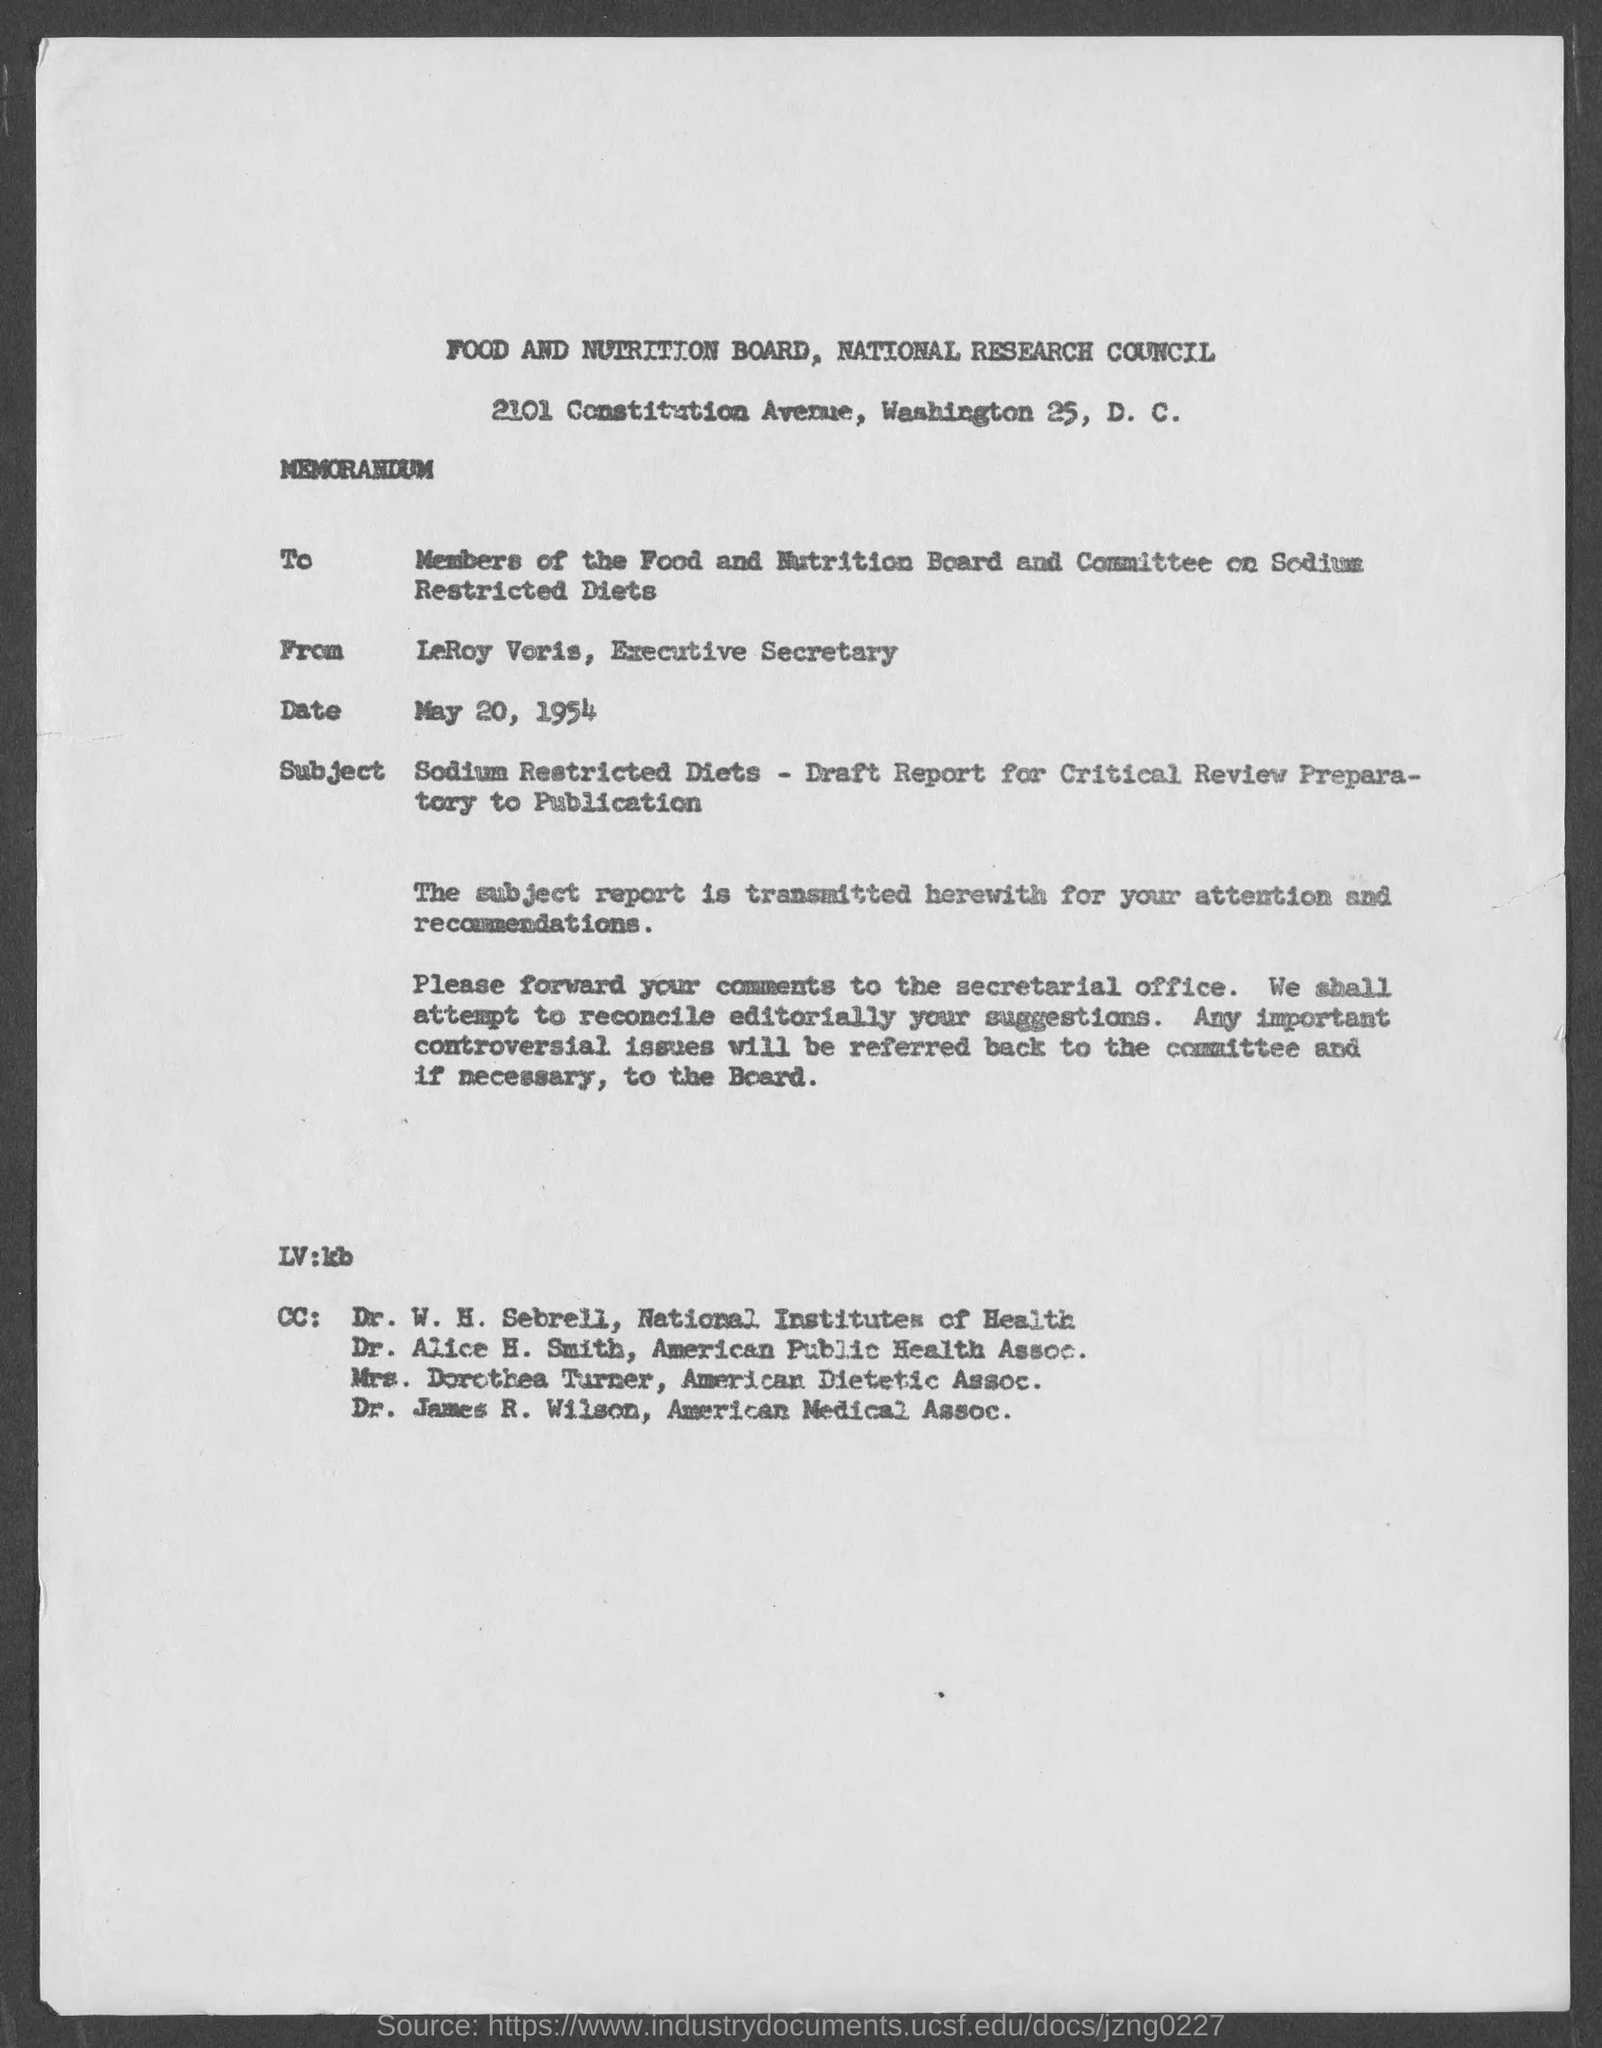Specify some key components in this picture. Mrs. Dorothea Turner is a member of the American Dietetic Association. The memorandum is dated May 20, 1954. LeRoy Voris holds the position of Executive Secretary. The from address in a memorandum is "LeRoy Voris, Executive Secretary. Dr. James R. Wilson is a member of the American Medical Association. 